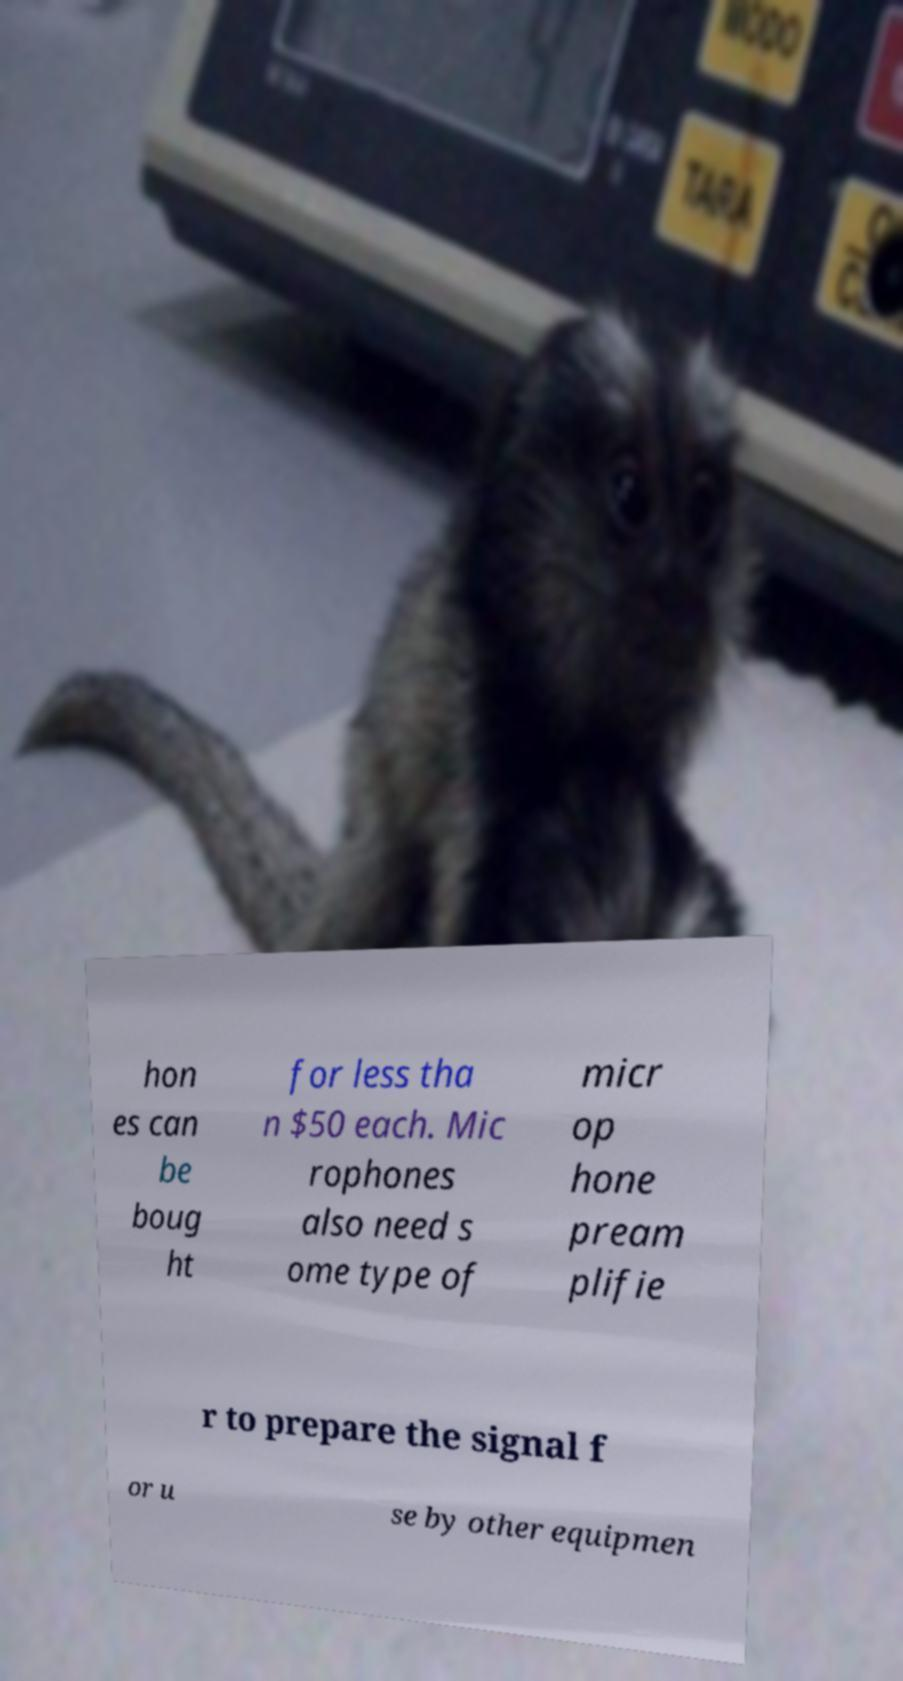There's text embedded in this image that I need extracted. Can you transcribe it verbatim? hon es can be boug ht for less tha n $50 each. Mic rophones also need s ome type of micr op hone pream plifie r to prepare the signal f or u se by other equipmen 